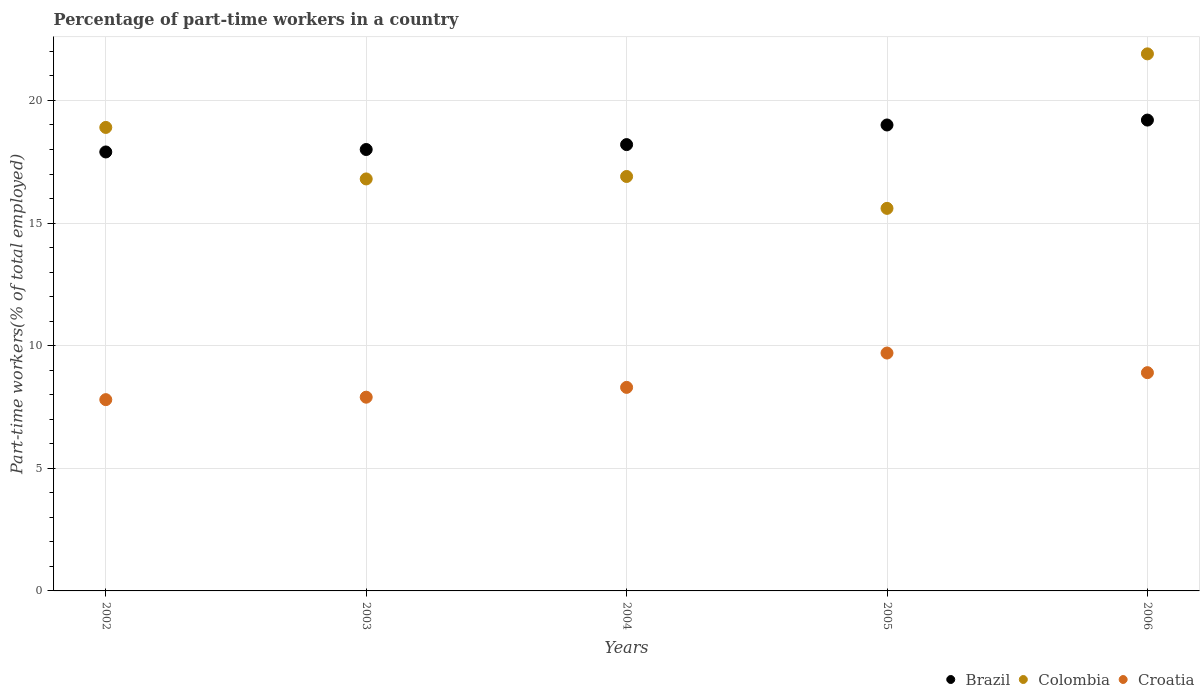How many different coloured dotlines are there?
Keep it short and to the point. 3. Is the number of dotlines equal to the number of legend labels?
Provide a short and direct response. Yes. What is the percentage of part-time workers in Brazil in 2004?
Your answer should be very brief. 18.2. Across all years, what is the maximum percentage of part-time workers in Croatia?
Offer a very short reply. 9.7. Across all years, what is the minimum percentage of part-time workers in Brazil?
Make the answer very short. 17.9. In which year was the percentage of part-time workers in Croatia maximum?
Your answer should be very brief. 2005. In which year was the percentage of part-time workers in Brazil minimum?
Offer a very short reply. 2002. What is the total percentage of part-time workers in Brazil in the graph?
Provide a short and direct response. 92.3. What is the difference between the percentage of part-time workers in Croatia in 2002 and that in 2003?
Ensure brevity in your answer.  -0.1. What is the difference between the percentage of part-time workers in Brazil in 2006 and the percentage of part-time workers in Colombia in 2002?
Offer a very short reply. 0.3. What is the average percentage of part-time workers in Brazil per year?
Keep it short and to the point. 18.46. In the year 2002, what is the difference between the percentage of part-time workers in Croatia and percentage of part-time workers in Colombia?
Your answer should be compact. -11.1. In how many years, is the percentage of part-time workers in Croatia greater than 4 %?
Your answer should be compact. 5. What is the ratio of the percentage of part-time workers in Colombia in 2004 to that in 2006?
Your answer should be very brief. 0.77. Is the difference between the percentage of part-time workers in Croatia in 2004 and 2005 greater than the difference between the percentage of part-time workers in Colombia in 2004 and 2005?
Offer a very short reply. No. What is the difference between the highest and the second highest percentage of part-time workers in Colombia?
Offer a very short reply. 3. What is the difference between the highest and the lowest percentage of part-time workers in Colombia?
Offer a very short reply. 6.3. In how many years, is the percentage of part-time workers in Croatia greater than the average percentage of part-time workers in Croatia taken over all years?
Your response must be concise. 2. Is the sum of the percentage of part-time workers in Croatia in 2002 and 2005 greater than the maximum percentage of part-time workers in Brazil across all years?
Provide a short and direct response. No. Is it the case that in every year, the sum of the percentage of part-time workers in Croatia and percentage of part-time workers in Brazil  is greater than the percentage of part-time workers in Colombia?
Provide a short and direct response. Yes. Is the percentage of part-time workers in Colombia strictly less than the percentage of part-time workers in Croatia over the years?
Give a very brief answer. No. How many years are there in the graph?
Ensure brevity in your answer.  5. What is the difference between two consecutive major ticks on the Y-axis?
Your answer should be compact. 5. Are the values on the major ticks of Y-axis written in scientific E-notation?
Your answer should be compact. No. How many legend labels are there?
Provide a succinct answer. 3. What is the title of the graph?
Provide a short and direct response. Percentage of part-time workers in a country. What is the label or title of the X-axis?
Provide a short and direct response. Years. What is the label or title of the Y-axis?
Your response must be concise. Part-time workers(% of total employed). What is the Part-time workers(% of total employed) in Brazil in 2002?
Offer a terse response. 17.9. What is the Part-time workers(% of total employed) in Colombia in 2002?
Give a very brief answer. 18.9. What is the Part-time workers(% of total employed) in Croatia in 2002?
Your answer should be very brief. 7.8. What is the Part-time workers(% of total employed) in Colombia in 2003?
Provide a short and direct response. 16.8. What is the Part-time workers(% of total employed) of Croatia in 2003?
Keep it short and to the point. 7.9. What is the Part-time workers(% of total employed) in Brazil in 2004?
Offer a terse response. 18.2. What is the Part-time workers(% of total employed) of Colombia in 2004?
Make the answer very short. 16.9. What is the Part-time workers(% of total employed) of Croatia in 2004?
Provide a succinct answer. 8.3. What is the Part-time workers(% of total employed) of Colombia in 2005?
Your response must be concise. 15.6. What is the Part-time workers(% of total employed) of Croatia in 2005?
Ensure brevity in your answer.  9.7. What is the Part-time workers(% of total employed) of Brazil in 2006?
Your answer should be very brief. 19.2. What is the Part-time workers(% of total employed) in Colombia in 2006?
Make the answer very short. 21.9. What is the Part-time workers(% of total employed) of Croatia in 2006?
Make the answer very short. 8.9. Across all years, what is the maximum Part-time workers(% of total employed) of Brazil?
Keep it short and to the point. 19.2. Across all years, what is the maximum Part-time workers(% of total employed) in Colombia?
Give a very brief answer. 21.9. Across all years, what is the maximum Part-time workers(% of total employed) of Croatia?
Your answer should be very brief. 9.7. Across all years, what is the minimum Part-time workers(% of total employed) of Brazil?
Provide a succinct answer. 17.9. Across all years, what is the minimum Part-time workers(% of total employed) of Colombia?
Keep it short and to the point. 15.6. Across all years, what is the minimum Part-time workers(% of total employed) of Croatia?
Provide a short and direct response. 7.8. What is the total Part-time workers(% of total employed) in Brazil in the graph?
Offer a very short reply. 92.3. What is the total Part-time workers(% of total employed) in Colombia in the graph?
Keep it short and to the point. 90.1. What is the total Part-time workers(% of total employed) of Croatia in the graph?
Ensure brevity in your answer.  42.6. What is the difference between the Part-time workers(% of total employed) of Croatia in 2002 and that in 2003?
Make the answer very short. -0.1. What is the difference between the Part-time workers(% of total employed) in Brazil in 2002 and that in 2005?
Offer a very short reply. -1.1. What is the difference between the Part-time workers(% of total employed) of Colombia in 2002 and that in 2005?
Your answer should be compact. 3.3. What is the difference between the Part-time workers(% of total employed) in Croatia in 2002 and that in 2005?
Offer a terse response. -1.9. What is the difference between the Part-time workers(% of total employed) of Brazil in 2002 and that in 2006?
Offer a terse response. -1.3. What is the difference between the Part-time workers(% of total employed) in Colombia in 2002 and that in 2006?
Ensure brevity in your answer.  -3. What is the difference between the Part-time workers(% of total employed) in Croatia in 2002 and that in 2006?
Your answer should be very brief. -1.1. What is the difference between the Part-time workers(% of total employed) of Brazil in 2003 and that in 2004?
Your response must be concise. -0.2. What is the difference between the Part-time workers(% of total employed) of Colombia in 2003 and that in 2004?
Offer a very short reply. -0.1. What is the difference between the Part-time workers(% of total employed) in Brazil in 2003 and that in 2005?
Give a very brief answer. -1. What is the difference between the Part-time workers(% of total employed) in Colombia in 2003 and that in 2006?
Your response must be concise. -5.1. What is the difference between the Part-time workers(% of total employed) in Croatia in 2003 and that in 2006?
Offer a terse response. -1. What is the difference between the Part-time workers(% of total employed) in Brazil in 2004 and that in 2005?
Give a very brief answer. -0.8. What is the difference between the Part-time workers(% of total employed) of Brazil in 2004 and that in 2006?
Provide a short and direct response. -1. What is the difference between the Part-time workers(% of total employed) of Colombia in 2004 and that in 2006?
Offer a terse response. -5. What is the difference between the Part-time workers(% of total employed) in Croatia in 2004 and that in 2006?
Your answer should be compact. -0.6. What is the difference between the Part-time workers(% of total employed) of Brazil in 2005 and that in 2006?
Offer a very short reply. -0.2. What is the difference between the Part-time workers(% of total employed) of Colombia in 2005 and that in 2006?
Provide a short and direct response. -6.3. What is the difference between the Part-time workers(% of total employed) in Croatia in 2005 and that in 2006?
Give a very brief answer. 0.8. What is the difference between the Part-time workers(% of total employed) in Brazil in 2002 and the Part-time workers(% of total employed) in Colombia in 2003?
Your answer should be compact. 1.1. What is the difference between the Part-time workers(% of total employed) in Brazil in 2002 and the Part-time workers(% of total employed) in Colombia in 2006?
Your answer should be compact. -4. What is the difference between the Part-time workers(% of total employed) in Colombia in 2002 and the Part-time workers(% of total employed) in Croatia in 2006?
Provide a short and direct response. 10. What is the difference between the Part-time workers(% of total employed) in Colombia in 2003 and the Part-time workers(% of total employed) in Croatia in 2004?
Offer a very short reply. 8.5. What is the difference between the Part-time workers(% of total employed) of Brazil in 2003 and the Part-time workers(% of total employed) of Croatia in 2005?
Ensure brevity in your answer.  8.3. What is the difference between the Part-time workers(% of total employed) in Brazil in 2003 and the Part-time workers(% of total employed) in Colombia in 2006?
Provide a short and direct response. -3.9. What is the difference between the Part-time workers(% of total employed) in Brazil in 2003 and the Part-time workers(% of total employed) in Croatia in 2006?
Make the answer very short. 9.1. What is the difference between the Part-time workers(% of total employed) of Brazil in 2004 and the Part-time workers(% of total employed) of Colombia in 2005?
Give a very brief answer. 2.6. What is the difference between the Part-time workers(% of total employed) in Brazil in 2004 and the Part-time workers(% of total employed) in Colombia in 2006?
Offer a terse response. -3.7. What is the difference between the Part-time workers(% of total employed) of Brazil in 2004 and the Part-time workers(% of total employed) of Croatia in 2006?
Offer a terse response. 9.3. What is the difference between the Part-time workers(% of total employed) in Colombia in 2004 and the Part-time workers(% of total employed) in Croatia in 2006?
Your answer should be compact. 8. What is the difference between the Part-time workers(% of total employed) of Brazil in 2005 and the Part-time workers(% of total employed) of Colombia in 2006?
Make the answer very short. -2.9. What is the difference between the Part-time workers(% of total employed) in Colombia in 2005 and the Part-time workers(% of total employed) in Croatia in 2006?
Your answer should be compact. 6.7. What is the average Part-time workers(% of total employed) in Brazil per year?
Offer a terse response. 18.46. What is the average Part-time workers(% of total employed) in Colombia per year?
Offer a terse response. 18.02. What is the average Part-time workers(% of total employed) of Croatia per year?
Give a very brief answer. 8.52. In the year 2002, what is the difference between the Part-time workers(% of total employed) of Brazil and Part-time workers(% of total employed) of Colombia?
Provide a succinct answer. -1. In the year 2002, what is the difference between the Part-time workers(% of total employed) of Brazil and Part-time workers(% of total employed) of Croatia?
Provide a short and direct response. 10.1. In the year 2003, what is the difference between the Part-time workers(% of total employed) in Brazil and Part-time workers(% of total employed) in Colombia?
Your answer should be compact. 1.2. In the year 2003, what is the difference between the Part-time workers(% of total employed) of Brazil and Part-time workers(% of total employed) of Croatia?
Your answer should be compact. 10.1. In the year 2003, what is the difference between the Part-time workers(% of total employed) of Colombia and Part-time workers(% of total employed) of Croatia?
Your answer should be very brief. 8.9. In the year 2004, what is the difference between the Part-time workers(% of total employed) in Brazil and Part-time workers(% of total employed) in Croatia?
Offer a very short reply. 9.9. In the year 2005, what is the difference between the Part-time workers(% of total employed) in Brazil and Part-time workers(% of total employed) in Colombia?
Your answer should be very brief. 3.4. In the year 2005, what is the difference between the Part-time workers(% of total employed) of Colombia and Part-time workers(% of total employed) of Croatia?
Offer a terse response. 5.9. In the year 2006, what is the difference between the Part-time workers(% of total employed) of Brazil and Part-time workers(% of total employed) of Colombia?
Make the answer very short. -2.7. In the year 2006, what is the difference between the Part-time workers(% of total employed) of Colombia and Part-time workers(% of total employed) of Croatia?
Your answer should be compact. 13. What is the ratio of the Part-time workers(% of total employed) in Colombia in 2002 to that in 2003?
Your answer should be very brief. 1.12. What is the ratio of the Part-time workers(% of total employed) of Croatia in 2002 to that in 2003?
Provide a succinct answer. 0.99. What is the ratio of the Part-time workers(% of total employed) in Brazil in 2002 to that in 2004?
Provide a succinct answer. 0.98. What is the ratio of the Part-time workers(% of total employed) in Colombia in 2002 to that in 2004?
Your response must be concise. 1.12. What is the ratio of the Part-time workers(% of total employed) of Croatia in 2002 to that in 2004?
Provide a short and direct response. 0.94. What is the ratio of the Part-time workers(% of total employed) in Brazil in 2002 to that in 2005?
Your answer should be very brief. 0.94. What is the ratio of the Part-time workers(% of total employed) of Colombia in 2002 to that in 2005?
Offer a very short reply. 1.21. What is the ratio of the Part-time workers(% of total employed) of Croatia in 2002 to that in 2005?
Offer a very short reply. 0.8. What is the ratio of the Part-time workers(% of total employed) in Brazil in 2002 to that in 2006?
Offer a very short reply. 0.93. What is the ratio of the Part-time workers(% of total employed) in Colombia in 2002 to that in 2006?
Ensure brevity in your answer.  0.86. What is the ratio of the Part-time workers(% of total employed) in Croatia in 2002 to that in 2006?
Keep it short and to the point. 0.88. What is the ratio of the Part-time workers(% of total employed) of Colombia in 2003 to that in 2004?
Offer a terse response. 0.99. What is the ratio of the Part-time workers(% of total employed) of Croatia in 2003 to that in 2004?
Your response must be concise. 0.95. What is the ratio of the Part-time workers(% of total employed) of Croatia in 2003 to that in 2005?
Give a very brief answer. 0.81. What is the ratio of the Part-time workers(% of total employed) of Colombia in 2003 to that in 2006?
Provide a short and direct response. 0.77. What is the ratio of the Part-time workers(% of total employed) of Croatia in 2003 to that in 2006?
Offer a terse response. 0.89. What is the ratio of the Part-time workers(% of total employed) of Brazil in 2004 to that in 2005?
Offer a terse response. 0.96. What is the ratio of the Part-time workers(% of total employed) of Croatia in 2004 to that in 2005?
Provide a succinct answer. 0.86. What is the ratio of the Part-time workers(% of total employed) in Brazil in 2004 to that in 2006?
Give a very brief answer. 0.95. What is the ratio of the Part-time workers(% of total employed) in Colombia in 2004 to that in 2006?
Your answer should be compact. 0.77. What is the ratio of the Part-time workers(% of total employed) of Croatia in 2004 to that in 2006?
Your response must be concise. 0.93. What is the ratio of the Part-time workers(% of total employed) of Colombia in 2005 to that in 2006?
Provide a short and direct response. 0.71. What is the ratio of the Part-time workers(% of total employed) in Croatia in 2005 to that in 2006?
Give a very brief answer. 1.09. What is the difference between the highest and the lowest Part-time workers(% of total employed) in Brazil?
Offer a very short reply. 1.3. What is the difference between the highest and the lowest Part-time workers(% of total employed) in Colombia?
Your answer should be very brief. 6.3. 